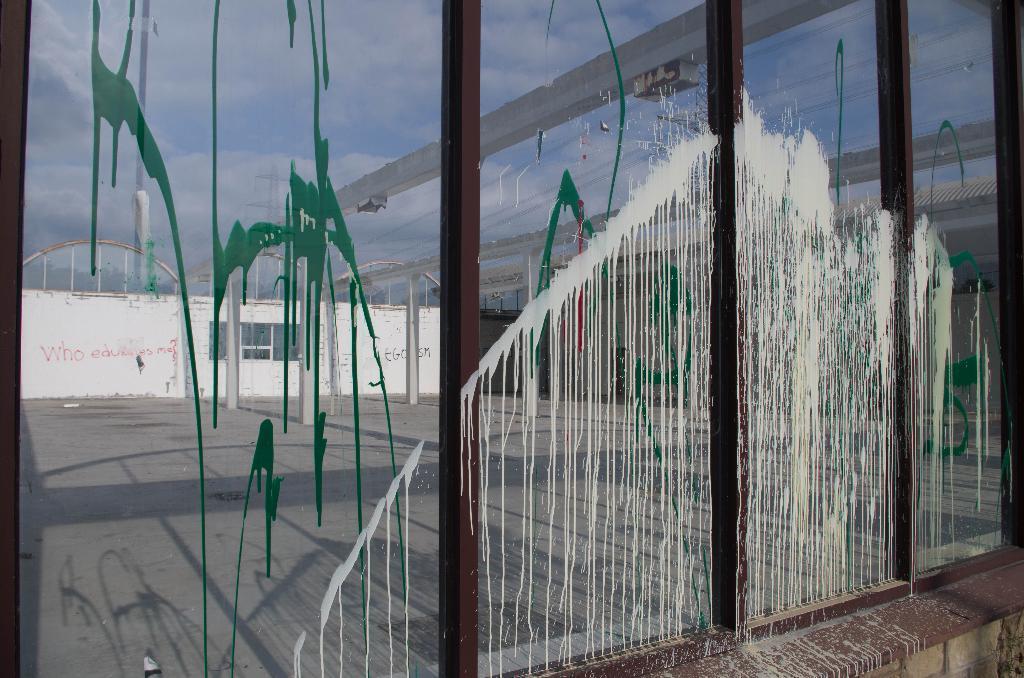Could you give a brief overview of what you see in this image? In this picture we can see a glass, from the glass we can see a wall and the sky, we can see painting on this glass. 